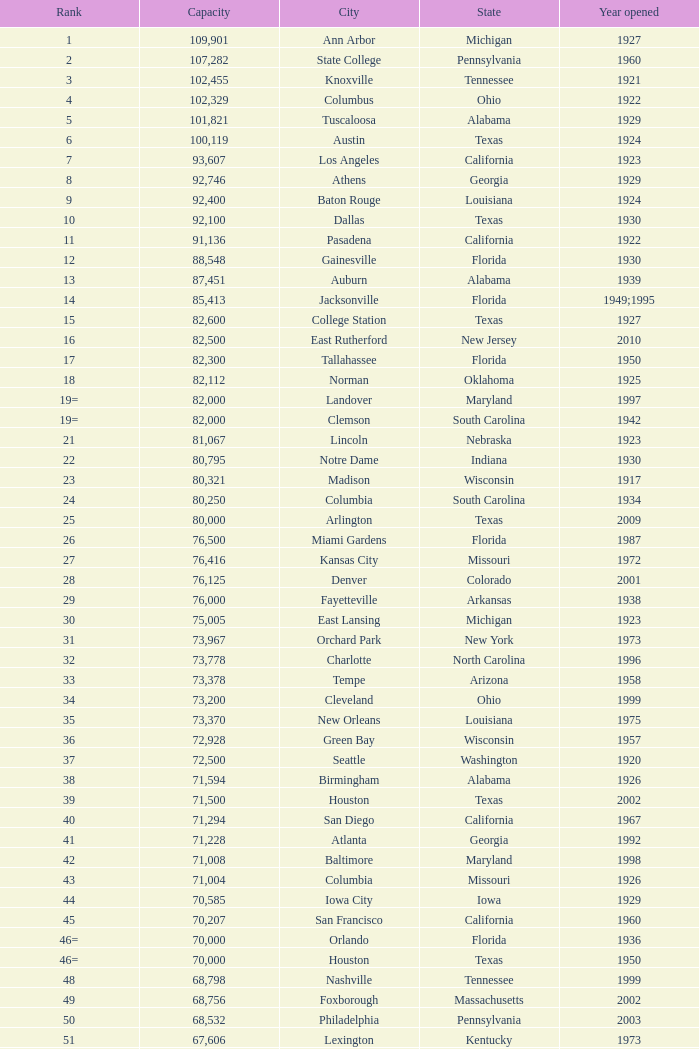What is the name of the city in alabama that was inaugurated in 1996? Huntsville. Could you help me parse every detail presented in this table? {'header': ['Rank', 'Capacity', 'City', 'State', 'Year opened'], 'rows': [['1', '109,901', 'Ann Arbor', 'Michigan', '1927'], ['2', '107,282', 'State College', 'Pennsylvania', '1960'], ['3', '102,455', 'Knoxville', 'Tennessee', '1921'], ['4', '102,329', 'Columbus', 'Ohio', '1922'], ['5', '101,821', 'Tuscaloosa', 'Alabama', '1929'], ['6', '100,119', 'Austin', 'Texas', '1924'], ['7', '93,607', 'Los Angeles', 'California', '1923'], ['8', '92,746', 'Athens', 'Georgia', '1929'], ['9', '92,400', 'Baton Rouge', 'Louisiana', '1924'], ['10', '92,100', 'Dallas', 'Texas', '1930'], ['11', '91,136', 'Pasadena', 'California', '1922'], ['12', '88,548', 'Gainesville', 'Florida', '1930'], ['13', '87,451', 'Auburn', 'Alabama', '1939'], ['14', '85,413', 'Jacksonville', 'Florida', '1949;1995'], ['15', '82,600', 'College Station', 'Texas', '1927'], ['16', '82,500', 'East Rutherford', 'New Jersey', '2010'], ['17', '82,300', 'Tallahassee', 'Florida', '1950'], ['18', '82,112', 'Norman', 'Oklahoma', '1925'], ['19=', '82,000', 'Landover', 'Maryland', '1997'], ['19=', '82,000', 'Clemson', 'South Carolina', '1942'], ['21', '81,067', 'Lincoln', 'Nebraska', '1923'], ['22', '80,795', 'Notre Dame', 'Indiana', '1930'], ['23', '80,321', 'Madison', 'Wisconsin', '1917'], ['24', '80,250', 'Columbia', 'South Carolina', '1934'], ['25', '80,000', 'Arlington', 'Texas', '2009'], ['26', '76,500', 'Miami Gardens', 'Florida', '1987'], ['27', '76,416', 'Kansas City', 'Missouri', '1972'], ['28', '76,125', 'Denver', 'Colorado', '2001'], ['29', '76,000', 'Fayetteville', 'Arkansas', '1938'], ['30', '75,005', 'East Lansing', 'Michigan', '1923'], ['31', '73,967', 'Orchard Park', 'New York', '1973'], ['32', '73,778', 'Charlotte', 'North Carolina', '1996'], ['33', '73,378', 'Tempe', 'Arizona', '1958'], ['34', '73,200', 'Cleveland', 'Ohio', '1999'], ['35', '73,370', 'New Orleans', 'Louisiana', '1975'], ['36', '72,928', 'Green Bay', 'Wisconsin', '1957'], ['37', '72,500', 'Seattle', 'Washington', '1920'], ['38', '71,594', 'Birmingham', 'Alabama', '1926'], ['39', '71,500', 'Houston', 'Texas', '2002'], ['40', '71,294', 'San Diego', 'California', '1967'], ['41', '71,228', 'Atlanta', 'Georgia', '1992'], ['42', '71,008', 'Baltimore', 'Maryland', '1998'], ['43', '71,004', 'Columbia', 'Missouri', '1926'], ['44', '70,585', 'Iowa City', 'Iowa', '1929'], ['45', '70,207', 'San Francisco', 'California', '1960'], ['46=', '70,000', 'Orlando', 'Florida', '1936'], ['46=', '70,000', 'Houston', 'Texas', '1950'], ['48', '68,798', 'Nashville', 'Tennessee', '1999'], ['49', '68,756', 'Foxborough', 'Massachusetts', '2002'], ['50', '68,532', 'Philadelphia', 'Pennsylvania', '2003'], ['51', '67,606', 'Lexington', 'Kentucky', '1973'], ['52', '67,000', 'Seattle', 'Washington', '2002'], ['53', '66,965', 'St. Louis', 'Missouri', '1995'], ['54', '66,233', 'Blacksburg', 'Virginia', '1965'], ['55', '65,857', 'Tampa', 'Florida', '1998'], ['56', '65,790', 'Cincinnati', 'Ohio', '2000'], ['57', '65,050', 'Pittsburgh', 'Pennsylvania', '2001'], ['58=', '65,000', 'San Antonio', 'Texas', '1993'], ['58=', '65,000', 'Detroit', 'Michigan', '2002'], ['60', '64,269', 'New Haven', 'Connecticut', '1914'], ['61', '64,111', 'Minneapolis', 'Minnesota', '1982'], ['62', '64,045', 'Provo', 'Utah', '1964'], ['63', '63,400', 'Glendale', 'Arizona', '2006'], ['64', '63,026', 'Oakland', 'California', '1966'], ['65', '63,000', 'Indianapolis', 'Indiana', '2008'], ['65', '63.000', 'Chapel Hill', 'North Carolina', '1926'], ['66', '62,872', 'Champaign', 'Illinois', '1923'], ['67', '62,717', 'Berkeley', 'California', '1923'], ['68', '61,500', 'Chicago', 'Illinois', '1924;2003'], ['69', '62,500', 'West Lafayette', 'Indiana', '1924'], ['70', '62,380', 'Memphis', 'Tennessee', '1965'], ['71', '61,500', 'Charlottesville', 'Virginia', '1931'], ['72', '61,000', 'Lubbock', 'Texas', '1947'], ['73', '60,580', 'Oxford', 'Mississippi', '1915'], ['74', '60,540', 'Morgantown', 'West Virginia', '1980'], ['75', '60,492', 'Jackson', 'Mississippi', '1941'], ['76', '60,000', 'Stillwater', 'Oklahoma', '1920'], ['78', '57,803', 'Tucson', 'Arizona', '1928'], ['79', '57,583', 'Raleigh', 'North Carolina', '1966'], ['80', '56,692', 'Washington, D.C.', 'District of Columbia', '1961'], ['81=', '56,000', 'Los Angeles', 'California', '1962'], ['81=', '56,000', 'Louisville', 'Kentucky', '1998'], ['83', '55,082', 'Starkville', 'Mississippi', '1914'], ['84=', '55,000', 'Atlanta', 'Georgia', '1913'], ['84=', '55,000', 'Ames', 'Iowa', '1975'], ['86', '53,800', 'Eugene', 'Oregon', '1967'], ['87', '53,750', 'Boulder', 'Colorado', '1924'], ['88', '53,727', 'Little Rock', 'Arkansas', '1948'], ['89', '53,500', 'Bloomington', 'Indiana', '1960'], ['90', '52,593', 'Philadelphia', 'Pennsylvania', '1895'], ['91', '52,480', 'Colorado Springs', 'Colorado', '1962'], ['92', '52,454', 'Piscataway', 'New Jersey', '1994'], ['93', '52,200', 'Manhattan', 'Kansas', '1968'], ['94=', '51,500', 'College Park', 'Maryland', '1950'], ['94=', '51,500', 'El Paso', 'Texas', '1963'], ['96', '50,832', 'Shreveport', 'Louisiana', '1925'], ['97', '50,805', 'Minneapolis', 'Minnesota', '2009'], ['98', '50,445', 'Denver', 'Colorado', '1995'], ['99', '50,291', 'Bronx', 'New York', '2009'], ['100', '50,096', 'Atlanta', 'Georgia', '1996'], ['101', '50,071', 'Lawrence', 'Kansas', '1921'], ['102=', '50,000', 'Honolulu', 'Hawai ʻ i', '1975'], ['102=', '50,000', 'Greenville', 'North Carolina', '1963'], ['102=', '50,000', 'Waco', 'Texas', '1950'], ['102=', '50,000', 'Stanford', 'California', '1921;2006'], ['106', '49,262', 'Syracuse', 'New York', '1980'], ['107', '49,115', 'Arlington', 'Texas', '1994'], ['108', '49,033', 'Phoenix', 'Arizona', '1998'], ['109', '48,876', 'Baltimore', 'Maryland', '1992'], ['110', '47,130', 'Evanston', 'Illinois', '1996'], ['111', '47,116', 'Seattle', 'Washington', '1999'], ['112', '46,861', 'St. Louis', 'Missouri', '2006'], ['113', '45,674', 'Corvallis', 'Oregon', '1953'], ['114', '45,634', 'Salt Lake City', 'Utah', '1998'], ['115', '45,301', 'Orlando', 'Florida', '2007'], ['116', '45,050', 'Anaheim', 'California', '1966'], ['117', '44,500', 'Chestnut Hill', 'Massachusetts', '1957'], ['118', '44,008', 'Fort Worth', 'Texas', '1930'], ['119', '43,647', 'Philadelphia', 'Pennsylvania', '2004'], ['120', '43,545', 'Cleveland', 'Ohio', '1994'], ['121', '42,445', 'San Diego', 'California', '2004'], ['122', '42,059', 'Cincinnati', 'Ohio', '2003'], ['123', '41,900', 'Milwaukee', 'Wisconsin', '2001'], ['124', '41,888', 'Washington, D.C.', 'District of Columbia', '2008'], ['125', '41,800', 'Flushing, New York', 'New York', '2009'], ['126', '41,782', 'Detroit', 'Michigan', '2000'], ['127', '41,503', 'San Francisco', 'California', '2000'], ['128', '41,160', 'Chicago', 'Illinois', '1914'], ['129', '41,031', 'Fresno', 'California', '1980'], ['130', '40,950', 'Houston', 'Texas', '2000'], ['131', '40,646', 'Mobile', 'Alabama', '1948'], ['132', '40,615', 'Chicago', 'Illinois', '1991'], ['133', '40,094', 'Albuquerque', 'New Mexico', '1960'], ['134=', '40,000', 'South Williamsport', 'Pennsylvania', '1959'], ['134=', '40,000', 'East Hartford', 'Connecticut', '2003'], ['134=', '40,000', 'West Point', 'New York', '1924'], ['137', '39,790', 'Nashville', 'Tennessee', '1922'], ['138', '39,504', 'Minneapolis', 'Minnesota', '2010'], ['139', '39,000', 'Kansas City', 'Missouri', '1973'], ['140', '38,496', 'Pittsburgh', 'Pennsylvania', '2001'], ['141', '38,019', 'Huntington', 'West Virginia', '1991'], ['142', '37,402', 'Boston', 'Massachusetts', '1912'], ['143=', '37,000', 'Boise', 'Idaho', '1970'], ['143=', '37,000', 'Miami', 'Florida', '2012'], ['145', '36,973', 'St. Petersburg', 'Florida', '1990'], ['146', '36,800', 'Whitney', 'Nevada', '1971'], ['147', '36,000', 'Hattiesburg', 'Mississippi', '1932'], ['148', '35,117', 'Pullman', 'Washington', '1972'], ['149', '35,097', 'Cincinnati', 'Ohio', '1924'], ['150', '34,400', 'Fort Collins', 'Colorado', '1968'], ['151', '34,000', 'Annapolis', 'Maryland', '1959'], ['152', '33,941', 'Durham', 'North Carolina', '1929'], ['153', '32,580', 'Laramie', 'Wyoming', '1950'], ['154=', '32,000', 'University Park', 'Texas', '2000'], ['154=', '32,000', 'Houston', 'Texas', '1942'], ['156', '31,500', 'Winston-Salem', 'North Carolina', '1968'], ['157=', '31,000', 'Lafayette', 'Louisiana', '1971'], ['157=', '31,000', 'Akron', 'Ohio', '1940'], ['157=', '31,000', 'DeKalb', 'Illinois', '1965'], ['160', '30,964', 'Jonesboro', 'Arkansas', '1974'], ['161', '30,850', 'Denton', 'Texas', '2011'], ['162', '30,600', 'Ruston', 'Louisiana', '1960'], ['163', '30,456', 'San Jose', 'California', '1933'], ['164', '30,427', 'Monroe', 'Louisiana', '1978'], ['165', '30,343', 'Las Cruces', 'New Mexico', '1978'], ['166', '30,323', 'Allston', 'Massachusetts', '1903'], ['167', '30,295', 'Mount Pleasant', 'Michigan', '1972'], ['168=', '30,200', 'Ypsilanti', 'Michigan', '1969'], ['168=', '30,200', 'Kalamazoo', 'Michigan', '1939'], ['168=', '30,000', 'Boca Raton', 'Florida', '2011'], ['168=', '30,000', 'San Marcos', 'Texas', '1981'], ['168=', '30,000', 'Tulsa', 'Oklahoma', '1930'], ['168=', '30,000', 'Akron', 'Ohio', '2009'], ['168=', '30,000', 'Troy', 'Alabama', '1950'], ['168=', '30,000', 'Norfolk', 'Virginia', '1997'], ['176', '29,993', 'Reno', 'Nevada', '1966'], ['177', '29,013', 'Amherst', 'New York', '1993'], ['178', '29,000', 'Baton Rouge', 'Louisiana', '1928'], ['179', '28,646', 'Spokane', 'Washington', '1950'], ['180', '27,800', 'Princeton', 'New Jersey', '1998'], ['181', '27,000', 'Carson', 'California', '2003'], ['182', '26,248', 'Toledo', 'Ohio', '1937'], ['183', '25,600', 'Grambling', 'Louisiana', '1983'], ['184', '25,597', 'Ithaca', 'New York', '1915'], ['185', '25,500', 'Tallahassee', 'Florida', '1957'], ['186', '25,400', 'Muncie', 'Indiana', '1967'], ['187', '25,200', 'Missoula', 'Montana', '1986'], ['188', '25,189', 'Harrison', 'New Jersey', '2010'], ['189', '25,000', 'Kent', 'Ohio', '1969'], ['190', '24,877', 'Harrisonburg', 'Virginia', '1975'], ['191', '24,600', 'Montgomery', 'Alabama', '1922'], ['192', '24,286', 'Oxford', 'Ohio', '1983'], ['193=', '24,000', 'Omaha', 'Nebraska', '2011'], ['193=', '24,000', 'Athens', 'Ohio', '1929'], ['194', '23,724', 'Bowling Green', 'Ohio', '1966'], ['195', '23,500', 'Worcester', 'Massachusetts', '1924'], ['196', '22,500', 'Lorman', 'Mississippi', '1992'], ['197=', '22,000', 'Houston', 'Texas', '2012'], ['197=', '22,000', 'Newark', 'Delaware', '1952'], ['197=', '22,000', 'Bowling Green', 'Kentucky', '1968'], ['197=', '22,000', 'Orangeburg', 'South Carolina', '1955'], ['201', '21,650', 'Boone', 'North Carolina', '1962'], ['202', '21,500', 'Greensboro', 'North Carolina', '1981'], ['203', '21,650', 'Sacramento', 'California', '1969'], ['204=', '21,000', 'Charleston', 'South Carolina', '1946'], ['204=', '21,000', 'Huntsville', 'Alabama', '1996'], ['204=', '21,000', 'Chicago', 'Illinois', '1994'], ['207', '20,668', 'Chattanooga', 'Tennessee', '1997'], ['208', '20,630', 'Youngstown', 'Ohio', '1982'], ['209', '20,500', 'Frisco', 'Texas', '2005'], ['210', '20,455', 'Columbus', 'Ohio', '1999'], ['211', '20,450', 'Fort Lauderdale', 'Florida', '1959'], ['212', '20,438', 'Portland', 'Oregon', '1926'], ['213', '20,311', 'Sacramento, California', 'California', '1928'], ['214', '20,066', 'Detroit, Michigan', 'Michigan', '1979'], ['215', '20,008', 'Sandy', 'Utah', '2008'], ['216=', '20,000', 'Providence', 'Rhode Island', '1925'], ['216=', '20,000', 'Miami', 'Florida', '1995'], ['216=', '20,000', 'Richmond', 'Kentucky', '1969'], ['216=', '20,000', 'Mesquite', 'Texas', '1977'], ['216=', '20,000', 'Canyon', 'Texas', '1959'], ['216=', '20,000', 'Bridgeview', 'Illinois', '2006']]} 